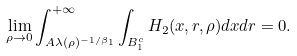Convert formula to latex. <formula><loc_0><loc_0><loc_500><loc_500>\lim _ { \rho \to 0 } \int _ { A \lambda ( \rho ) ^ { - 1 / \beta _ { 1 } } } ^ { + \infty } \int _ { B _ { 1 } ^ { c } } H _ { 2 } ( x , r , \rho ) d x d r = 0 .</formula> 